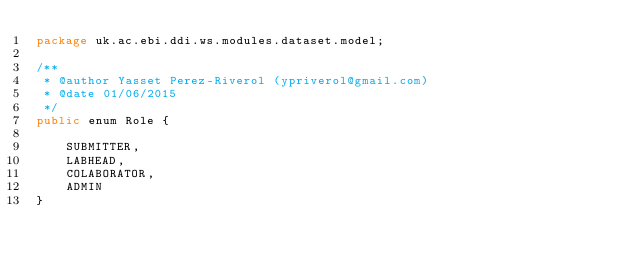Convert code to text. <code><loc_0><loc_0><loc_500><loc_500><_Java_>package uk.ac.ebi.ddi.ws.modules.dataset.model;

/**
 * @author Yasset Perez-Riverol (ypriverol@gmail.com)
 * @date 01/06/2015
 */
public enum Role {

    SUBMITTER,
    LABHEAD,
    COLABORATOR,
    ADMIN
}
</code> 